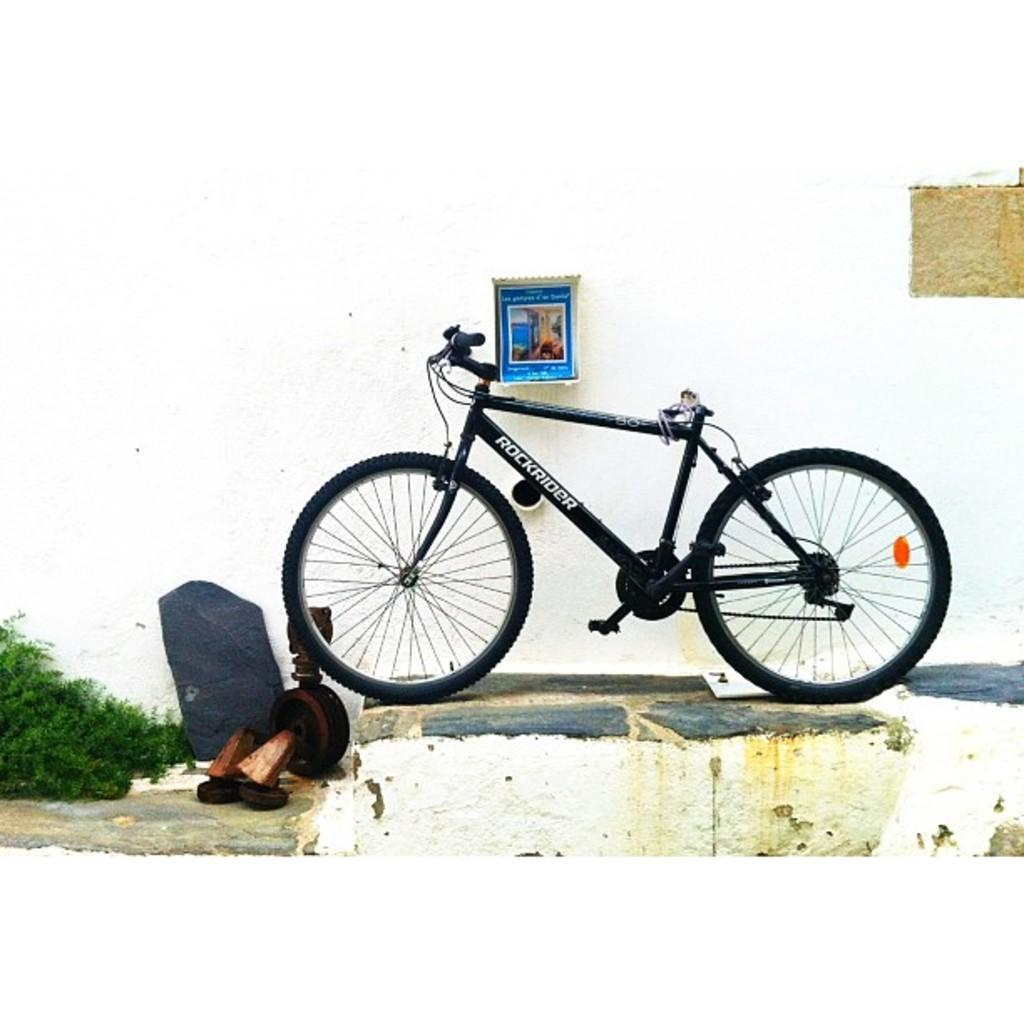What is the main subject of the image? The main subject of the image is a bicycle. What else can be seen in the image besides the bicycle? There are objects visible in the image, as well as grass. Can you describe the wall in the image? There is a wall with objects attached to it in the image. What type of nut is visible on the wall in the image? There is no nut visible on the wall in the image. What is the weather like in the image, considering the presence of clouds and the sun? There is no mention of clouds or the sun in the image, so it cannot be determined from the image alone. 